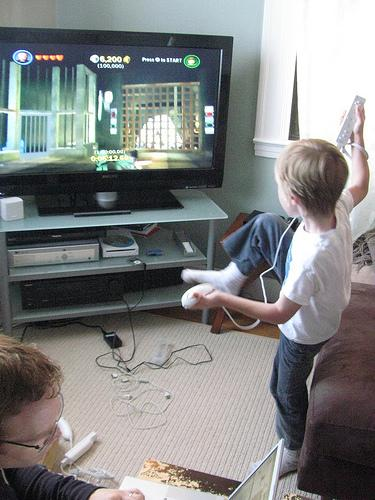In a formal tone, describe the principal subject in the image and their activity. The image depicts a young male child, who is wearing eyeglasses and actively participating in a video game displayed on a sizable television screen. Briefly describe the main character and their activity with a gaming device. A young, bespectacled boy is engaged in playing a Nintendo Wii video game on a huge flat screen TV. Describe the primary action taken by the child in the image and the object he is interacting with. In the photo, a little boy in a white tee shirt is playing an interactive video game using a Wii controller. Mention the electronics and activity present in the scene where the main character is featured. A blond child in a white t-shirt is using a Wii controller to play a video game displayed on a large black flatscreen television. State the central individual in the photograph and their engagement with an electronic device. The image captures a young boy wearing glasses, engrossed in playing a video game on a large television. Point out the key person in the image and what they are engaged in. The boy with blonde hair and glasses is immersed in a video game on a big television screen. Mention the main activity being carried out by the individual in the picture and the electronic device they are using. The young boy wearing glasses is playing a Nintendo Wii video game on a large flat screen television. Depict the core individual in the image and their interaction with a game console. A young boy sporting eyeglasses is enthusiastically playing a game on the Wii console, displaying the game on a sizeable television. Talk about the central figure in the picture and the digital entertainment they are enjoying. The little boy with glasses in the image is having fun playing a Wii video game on an impressively large TV. Write about the main person in the image and what they are doing using a casual tone. This blonde kid in the pic is having a blast playing a video game on a big flat screen TV. 